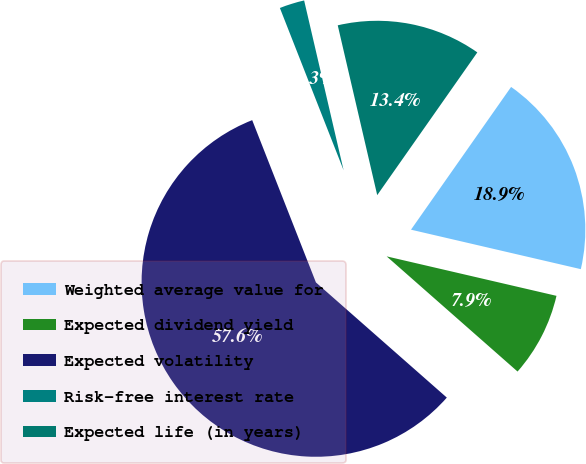Convert chart. <chart><loc_0><loc_0><loc_500><loc_500><pie_chart><fcel>Weighted average value for<fcel>Expected dividend yield<fcel>Expected volatility<fcel>Risk-free interest rate<fcel>Expected life (in years)<nl><fcel>18.9%<fcel>7.85%<fcel>57.56%<fcel>2.32%<fcel>13.37%<nl></chart> 